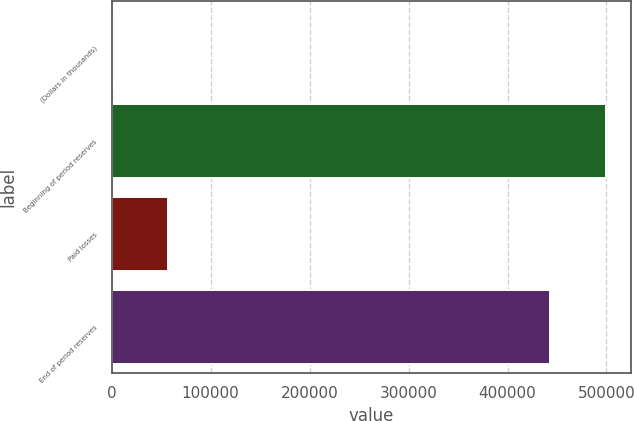<chart> <loc_0><loc_0><loc_500><loc_500><bar_chart><fcel>(Dollars in thousands)<fcel>Beginning of period reserves<fcel>Paid losses<fcel>End of period reserves<nl><fcel>2012<fcel>499911<fcel>57222<fcel>442821<nl></chart> 